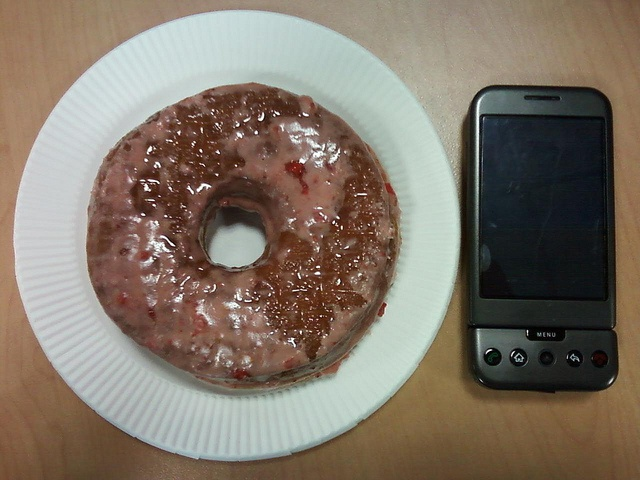Describe the objects in this image and their specific colors. I can see dining table in gray, lightgray, black, brown, and darkgray tones, donut in gray, maroon, and brown tones, and cell phone in gray, black, and purple tones in this image. 